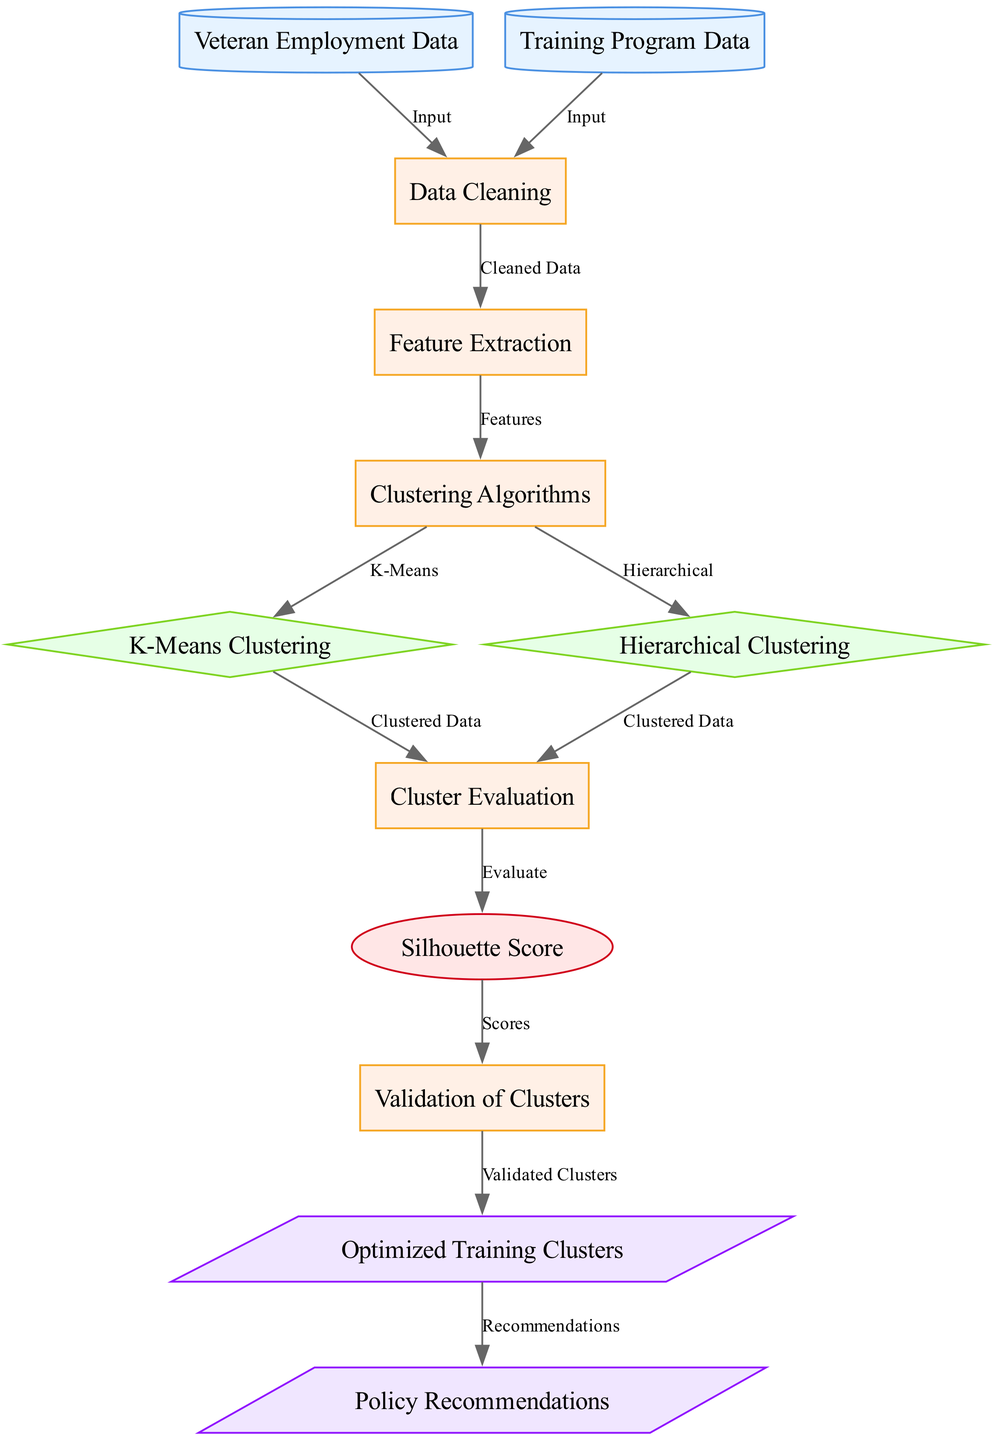What are the two data sources in the diagram? The two data sources listed in the diagram are "Veteran Employment Data" and "Training Program Data" which are identified as nodes 1 and 2.
Answer: Veteran Employment Data, Training Program Data How many processes are defined in the diagram? The diagram contains five defined processes, which are nodes 3, 4, 5, 8, and 10.
Answer: 5 What is the purpose of the "Feature Extraction" node? The "Feature Extraction" node, which is node 4, takes the cleaned data from "Data Cleaning" and extracts features from it to be used for clustering.
Answer: Extract features Which clustering algorithms are mentioned in the diagram? The diagram mentions two clustering algorithms: "K-Means Clustering" and "Hierarchical Clustering," represented as nodes 6 and 7, respectively.
Answer: K-Means Clustering, Hierarchical Clustering What metric is used for cluster evaluation? The metric used for evaluating the clusters in the diagram is the "Silhouette Score," which is represented as node 9.
Answer: Silhouette Score What is the final output of the clustering process? The final outputs of the clustering process are "Optimized Training Clusters" and "Policy Recommendations," represented as nodes 11 and 12.
Answer: Optimized Training Clusters, Policy Recommendations Which node follows the "Clustering Algorithms" node in the flow? The "Clustering Algorithms" node, which is node 5, leads to the "Cluster Evaluation" node, which is node 8, that follows it in the flow of the diagram.
Answer: Cluster Evaluation How are the clusters validated in the diagram? The clusters are validated in the diagram through the "Validation of Clusters" node, which is node 10, that takes validated clusters from node 9 (Silhouette Score) as input.
Answer: Through Validation of Clusters What flows into the "Data Cleaning" process? The inputs flowing into the "Data Cleaning" process, which is node 3, are the "Veteran Employment Data" and "Training Program Data."
Answer: Veteran Employment Data, Training Program Data 